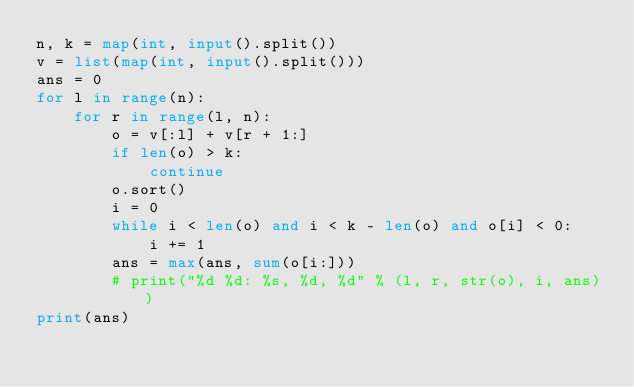<code> <loc_0><loc_0><loc_500><loc_500><_Python_>n, k = map(int, input().split())
v = list(map(int, input().split()))
ans = 0
for l in range(n):
	for r in range(l, n):
		o = v[:l] + v[r + 1:]
		if len(o) > k:
			continue
		o.sort()
		i = 0
		while i < len(o) and i < k - len(o) and o[i] < 0:
			i += 1
		ans = max(ans, sum(o[i:]))
		# print("%d %d: %s, %d, %d" % (l, r, str(o), i, ans))
print(ans)</code> 